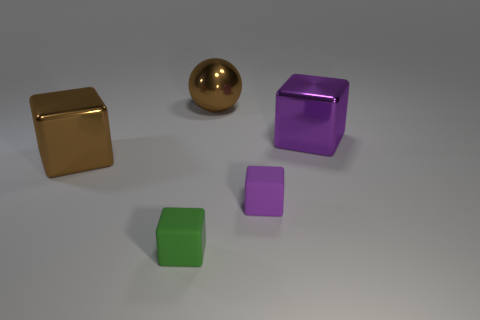There is a metal thing that is the same color as the metallic ball; what is its size?
Ensure brevity in your answer.  Large. There is a object that is the same color as the large ball; what is its shape?
Provide a short and direct response. Cube. Are there any other things that are the same color as the shiny ball?
Give a very brief answer. Yes. Is the number of tiny purple rubber objects that are to the right of the green rubber block less than the number of large red cubes?
Provide a short and direct response. No. Is the number of matte spheres greater than the number of big brown objects?
Make the answer very short. No. Is there a big block in front of the large block that is behind the large brown shiny thing in front of the ball?
Keep it short and to the point. Yes. How many other objects are there of the same size as the green rubber cube?
Offer a very short reply. 1. Are there any matte blocks behind the small green matte cube?
Give a very brief answer. Yes. There is a metal ball; is its color the same as the metal block that is on the left side of the big purple metal block?
Ensure brevity in your answer.  Yes. What is the color of the small object that is behind the small object on the left side of the tiny rubber object behind the green rubber cube?
Your answer should be very brief. Purple. 